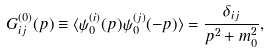<formula> <loc_0><loc_0><loc_500><loc_500>G _ { i j } ^ { ( 0 ) } ( { p } ) \equiv \langle \psi _ { 0 } ^ { ( i ) } ( { p } ) \psi _ { 0 } ^ { ( j ) } ( - { p } ) \rangle = \frac { \delta _ { i j } } { { p } ^ { 2 } + m _ { 0 } ^ { 2 } } ,</formula> 